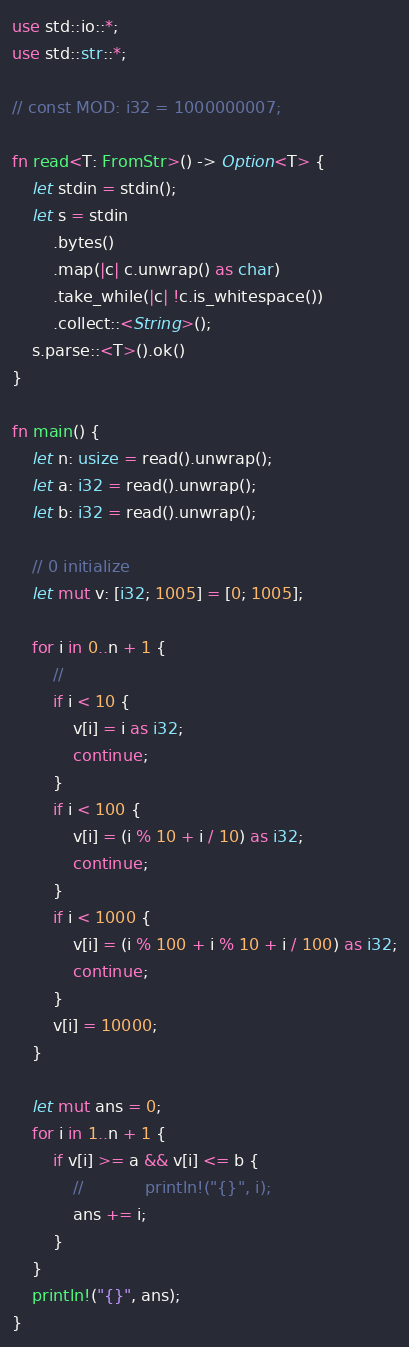<code> <loc_0><loc_0><loc_500><loc_500><_Rust_>use std::io::*;
use std::str::*;

// const MOD: i32 = 1000000007;

fn read<T: FromStr>() -> Option<T> {
    let stdin = stdin();
    let s = stdin
        .bytes()
        .map(|c| c.unwrap() as char)
        .take_while(|c| !c.is_whitespace())
        .collect::<String>();
    s.parse::<T>().ok()
}

fn main() {
    let n: usize = read().unwrap();
    let a: i32 = read().unwrap();
    let b: i32 = read().unwrap();

    // 0 initialize
    let mut v: [i32; 1005] = [0; 1005];

    for i in 0..n + 1 {
        //
        if i < 10 {
            v[i] = i as i32;
            continue;
        }
        if i < 100 {
            v[i] = (i % 10 + i / 10) as i32;
            continue;
        }
        if i < 1000 {
            v[i] = (i % 100 + i % 10 + i / 100) as i32;
            continue;
        }
        v[i] = 10000;
    }

    let mut ans = 0;
    for i in 1..n + 1 {
        if v[i] >= a && v[i] <= b {
            //            println!("{}", i);
            ans += i;
        }
    }
    println!("{}", ans);
}
</code> 